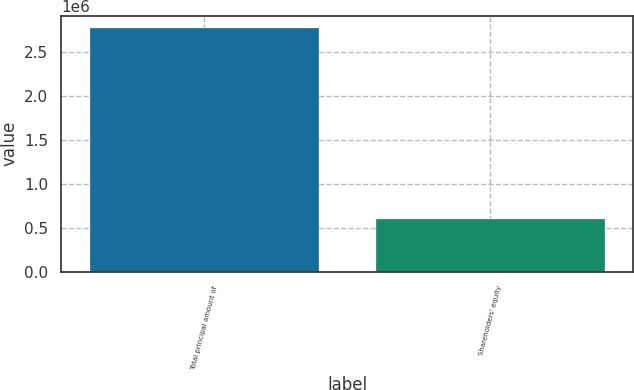<chart> <loc_0><loc_0><loc_500><loc_500><bar_chart><fcel>Total principal amount of<fcel>Shareholders' equity<nl><fcel>2.77101e+06<fcel>599949<nl></chart> 